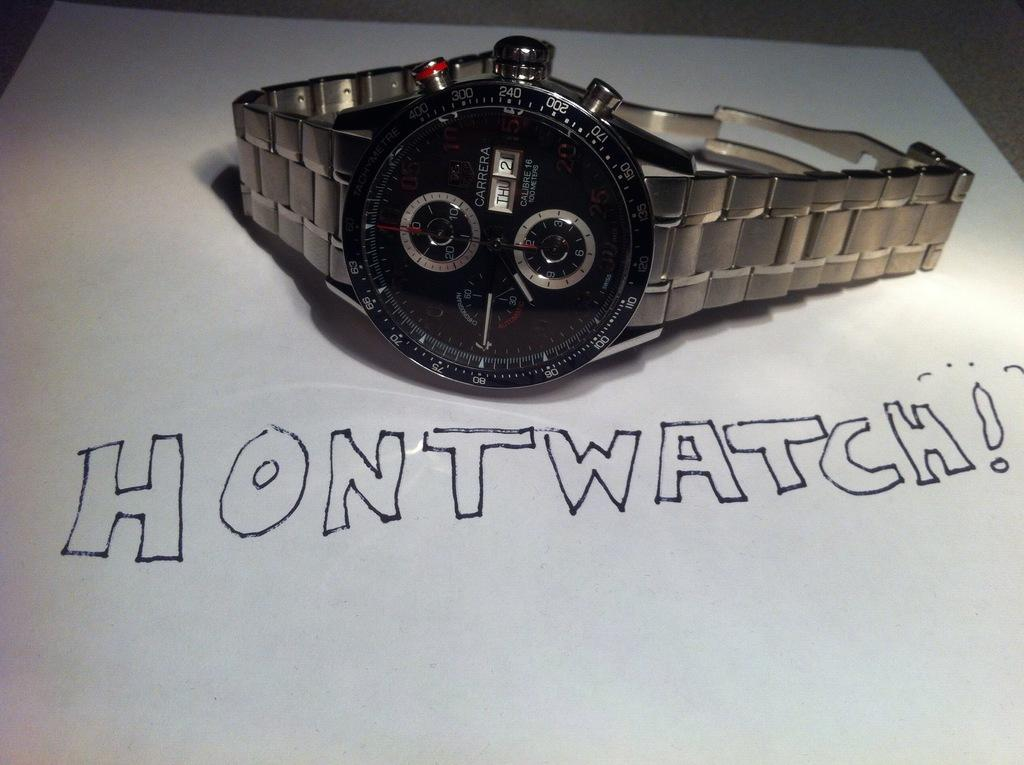<image>
Summarize the visual content of the image. A silver Carrera watch next to a paper with Hontwatch written on it. 